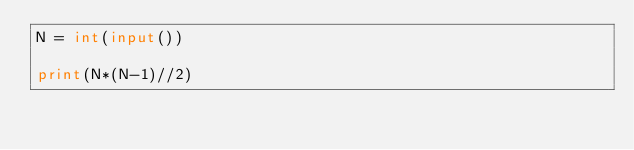<code> <loc_0><loc_0><loc_500><loc_500><_Python_>N = int(input())

print(N*(N-1)//2)</code> 